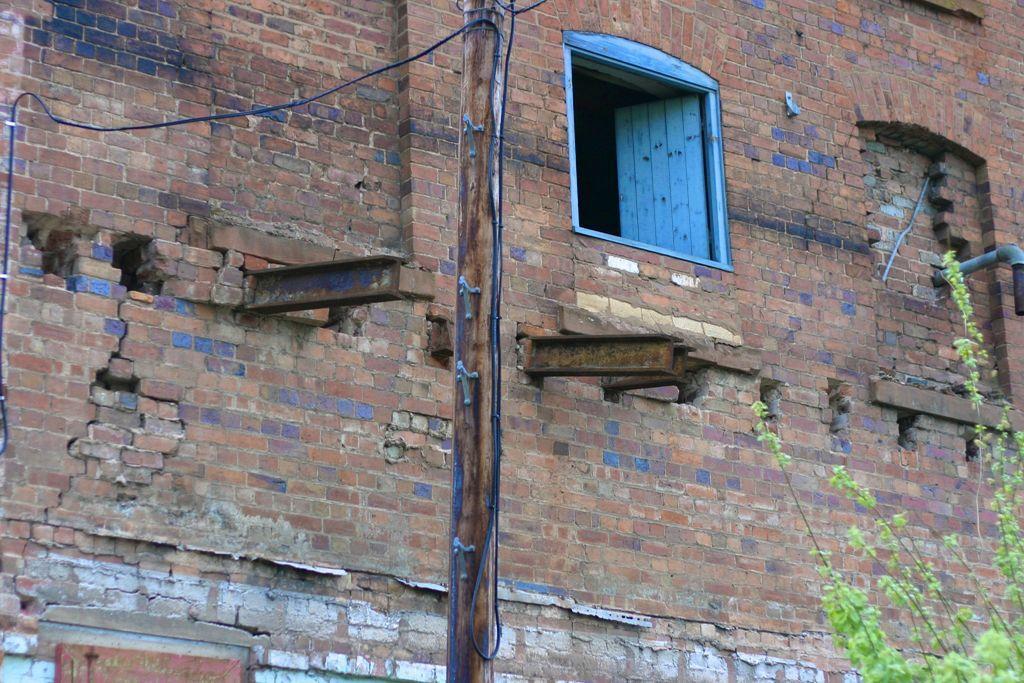Please provide a concise description of this image. In this image in front there is a wooden pole with the wire attached to it. Beside the pole there is a plant. On the backside of the image there is a wall with the window. 